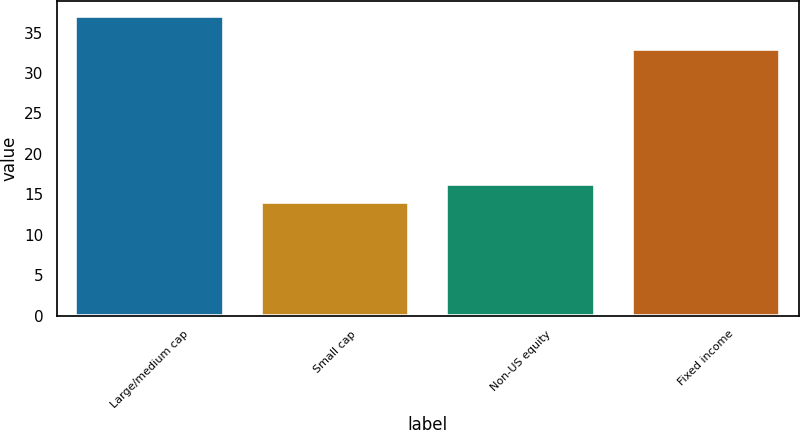<chart> <loc_0><loc_0><loc_500><loc_500><bar_chart><fcel>Large/medium cap<fcel>Small cap<fcel>Non-US equity<fcel>Fixed income<nl><fcel>37<fcel>14<fcel>16.3<fcel>33<nl></chart> 